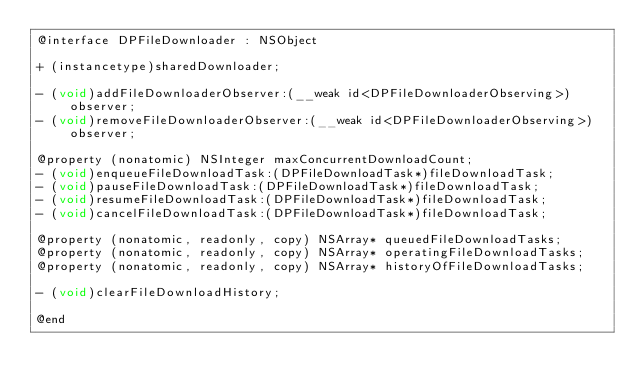Convert code to text. <code><loc_0><loc_0><loc_500><loc_500><_C_>@interface DPFileDownloader : NSObject

+ (instancetype)sharedDownloader;

- (void)addFileDownloaderObserver:(__weak id<DPFileDownloaderObserving>)observer;
- (void)removeFileDownloaderObserver:(__weak id<DPFileDownloaderObserving>)observer;

@property (nonatomic) NSInteger maxConcurrentDownloadCount;
- (void)enqueueFileDownloadTask:(DPFileDownloadTask*)fileDownloadTask;
- (void)pauseFileDownloadTask:(DPFileDownloadTask*)fileDownloadTask;
- (void)resumeFileDownloadTask:(DPFileDownloadTask*)fileDownloadTask;
- (void)cancelFileDownloadTask:(DPFileDownloadTask*)fileDownloadTask;

@property (nonatomic, readonly, copy) NSArray* queuedFileDownloadTasks;
@property (nonatomic, readonly, copy) NSArray* operatingFileDownloadTasks;
@property (nonatomic, readonly, copy) NSArray* historyOfFileDownloadTasks;

- (void)clearFileDownloadHistory;

@end
</code> 